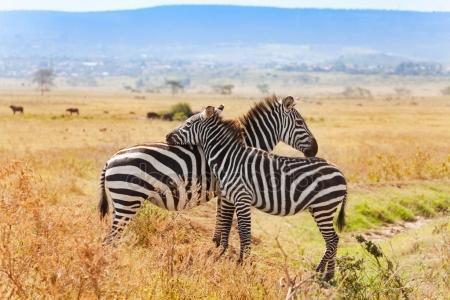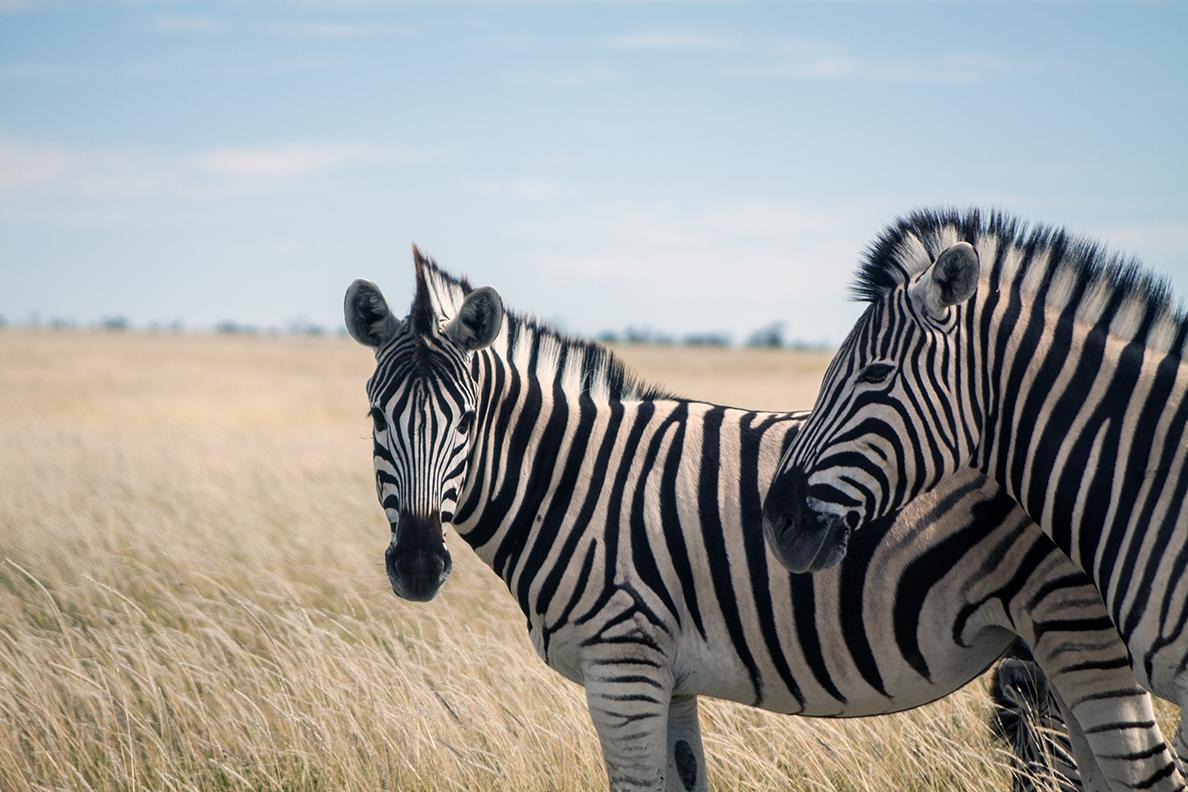The first image is the image on the left, the second image is the image on the right. For the images shown, is this caption "There are two zebras with there noses on the arch of the other zebras back." true? Answer yes or no. No. The first image is the image on the left, the second image is the image on the right. Evaluate the accuracy of this statement regarding the images: "The left image shows a right-turned zebra standing closest to the camera, with its head resting on the shoulders of a left-turned zebra, and the left-turned zebra with its head resting on the shoulders of the right-turned zebra.". Is it true? Answer yes or no. No. 